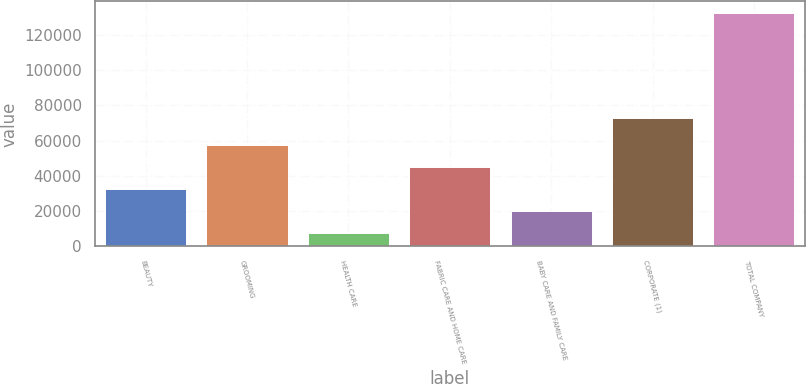Convert chart to OTSL. <chart><loc_0><loc_0><loc_500><loc_500><bar_chart><fcel>BEAUTY<fcel>GROOMING<fcel>HEALTH CARE<fcel>FABRIC CARE AND HOME CARE<fcel>BABY CARE AND FAMILY CARE<fcel>CORPORATE (1)<fcel>TOTAL COMPANY<nl><fcel>32449.6<fcel>57398.2<fcel>7501<fcel>44923.9<fcel>19975.3<fcel>72914<fcel>132244<nl></chart> 